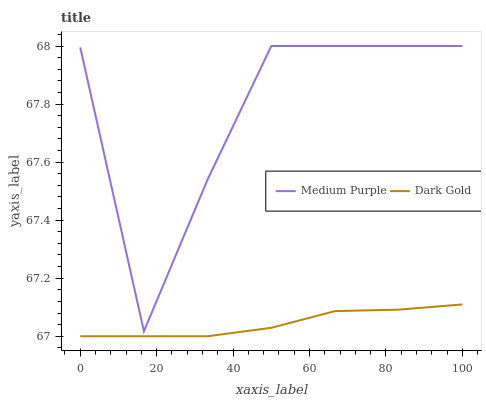Does Dark Gold have the minimum area under the curve?
Answer yes or no. Yes. Does Medium Purple have the maximum area under the curve?
Answer yes or no. Yes. Does Dark Gold have the maximum area under the curve?
Answer yes or no. No. Is Dark Gold the smoothest?
Answer yes or no. Yes. Is Medium Purple the roughest?
Answer yes or no. Yes. Is Dark Gold the roughest?
Answer yes or no. No. Does Dark Gold have the lowest value?
Answer yes or no. Yes. Does Medium Purple have the highest value?
Answer yes or no. Yes. Does Dark Gold have the highest value?
Answer yes or no. No. Is Dark Gold less than Medium Purple?
Answer yes or no. Yes. Is Medium Purple greater than Dark Gold?
Answer yes or no. Yes. Does Dark Gold intersect Medium Purple?
Answer yes or no. No. 